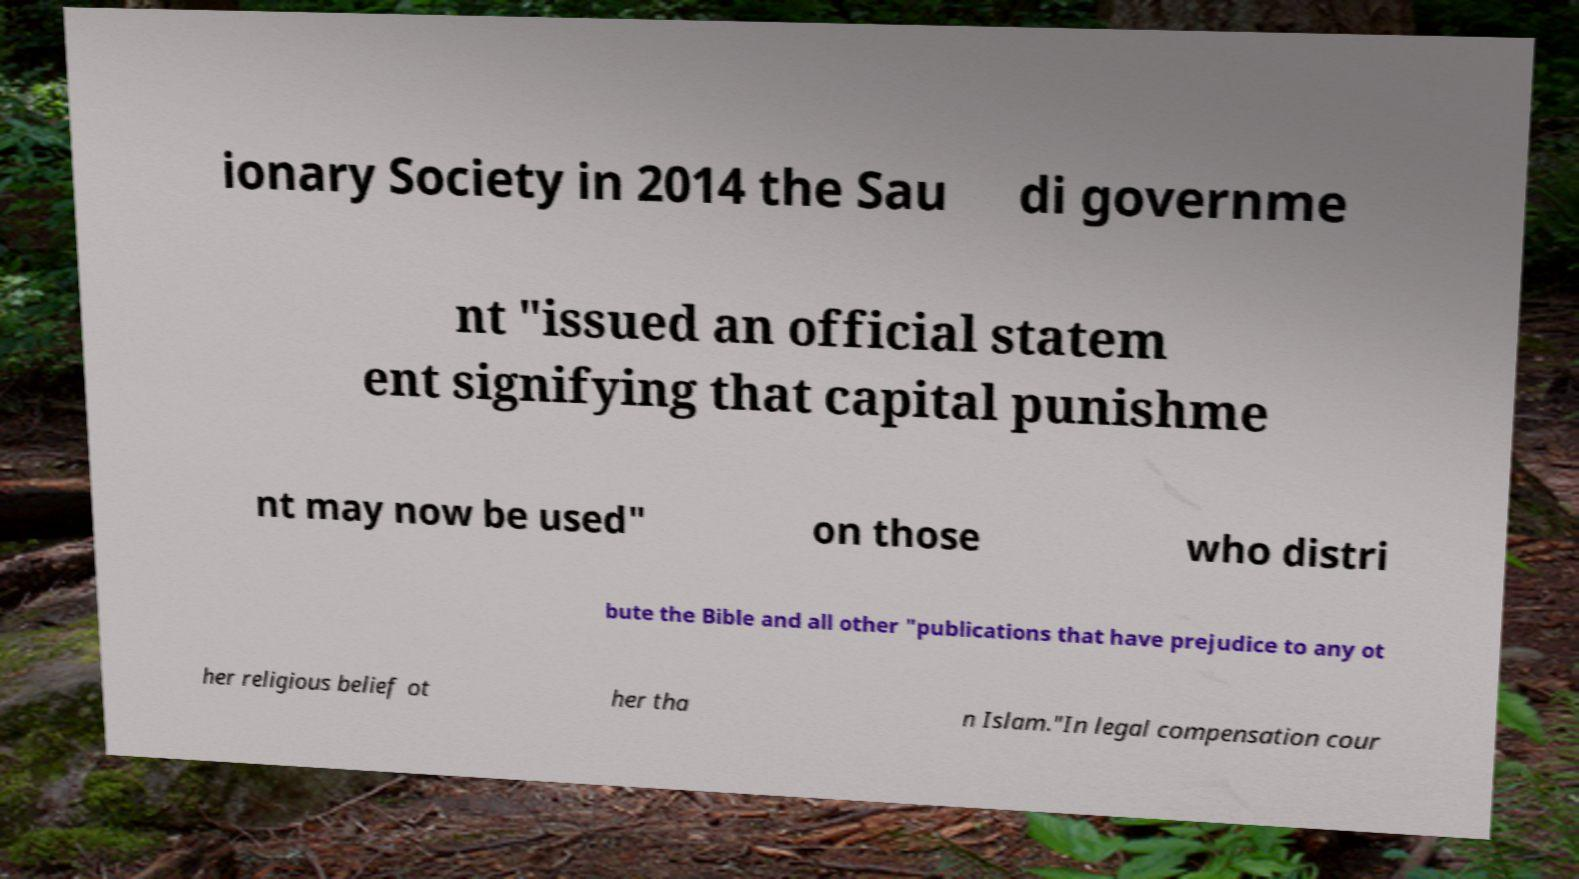Could you assist in decoding the text presented in this image and type it out clearly? ionary Society in 2014 the Sau di governme nt "issued an official statem ent signifying that capital punishme nt may now be used" on those who distri bute the Bible and all other "publications that have prejudice to any ot her religious belief ot her tha n Islam."In legal compensation cour 